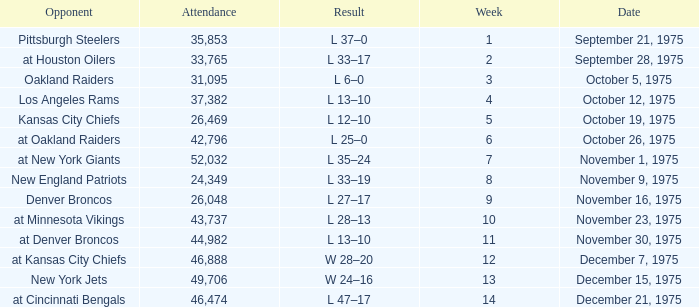What is the lowest Week when the result was l 13–10, November 30, 1975, with more than 44,982 people in attendance? None. 